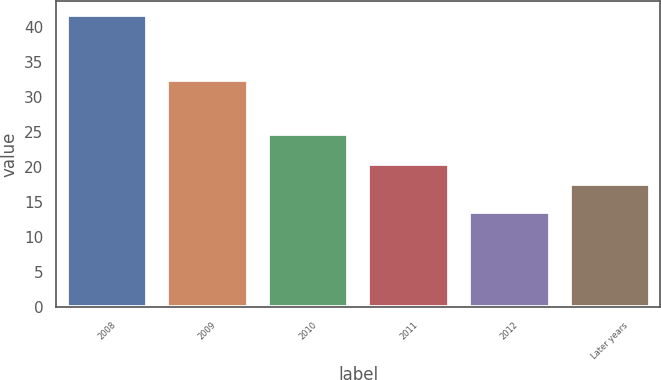Convert chart to OTSL. <chart><loc_0><loc_0><loc_500><loc_500><bar_chart><fcel>2008<fcel>2009<fcel>2010<fcel>2011<fcel>2012<fcel>Later years<nl><fcel>41.7<fcel>32.4<fcel>24.8<fcel>20.41<fcel>13.6<fcel>17.6<nl></chart> 